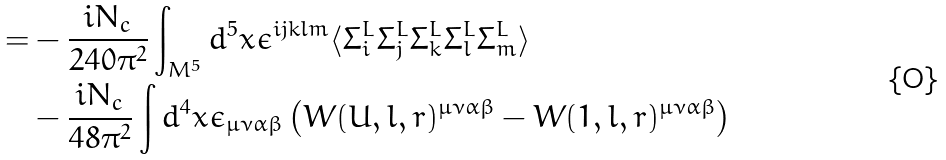Convert formula to latex. <formula><loc_0><loc_0><loc_500><loc_500>= & - \frac { i N _ { c } } { 2 4 0 \pi ^ { 2 } } \int _ { M ^ { 5 } } d ^ { 5 } x \epsilon ^ { i j k l m } \langle \Sigma ^ { L } _ { i } \Sigma ^ { L } _ { j } \Sigma ^ { L } _ { k } \Sigma ^ { L } _ { l } \Sigma ^ { L } _ { m } \rangle \\ & - \frac { i N _ { c } } { 4 8 \pi ^ { 2 } } \int d ^ { 4 } x \epsilon _ { \mu \nu \alpha \beta } \left ( W ( U , l , r ) ^ { \mu \nu \alpha \beta } - W ( 1 , l , r ) ^ { \mu \nu \alpha \beta } \right )</formula> 